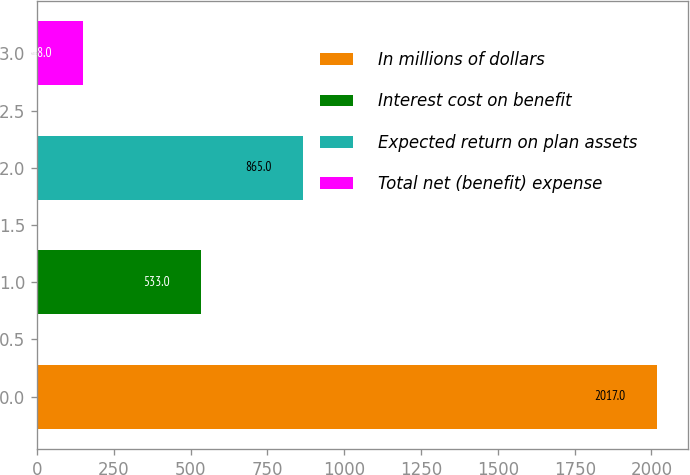Convert chart to OTSL. <chart><loc_0><loc_0><loc_500><loc_500><bar_chart><fcel>In millions of dollars<fcel>Interest cost on benefit<fcel>Expected return on plan assets<fcel>Total net (benefit) expense<nl><fcel>2017<fcel>533<fcel>865<fcel>148<nl></chart> 